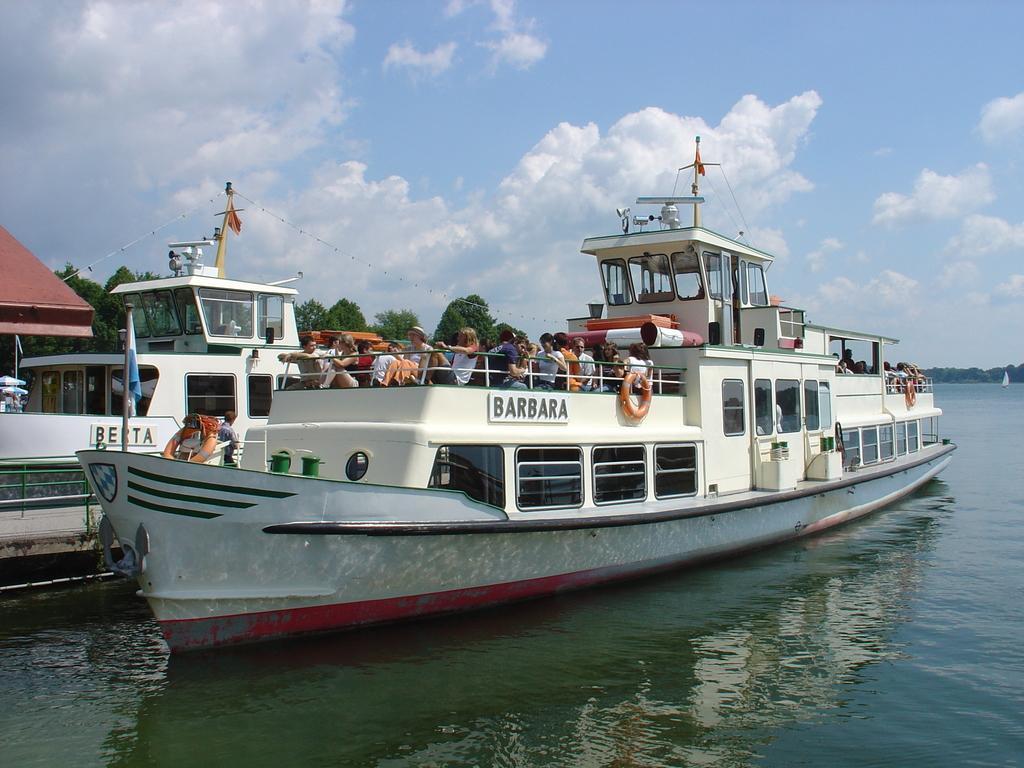Please provide a concise description of this image. There is a group of people present in a ship which is present on the surface of water as we can see in the middle of this image. There are trees in the background. The cloudy sky is at the top of this image. 